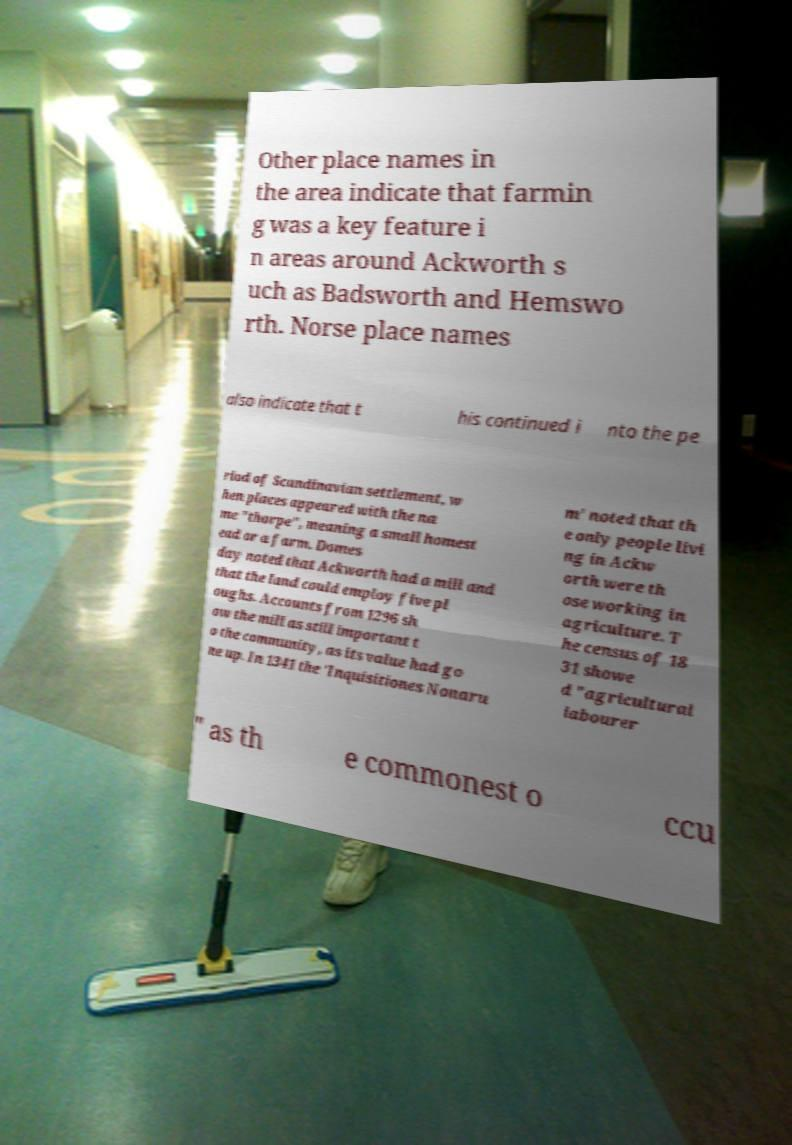Could you assist in decoding the text presented in this image and type it out clearly? Other place names in the area indicate that farmin g was a key feature i n areas around Ackworth s uch as Badsworth and Hemswo rth. Norse place names also indicate that t his continued i nto the pe riod of Scandinavian settlement, w hen places appeared with the na me "thorpe", meaning a small homest ead or a farm. Domes day noted that Ackworth had a mill and that the land could employ five pl oughs. Accounts from 1296 sh ow the mill as still important t o the community, as its value had go ne up. In 1341 the 'Inquisitiones Nonaru m' noted that th e only people livi ng in Ackw orth were th ose working in agriculture. T he census of 18 31 showe d "agricultural labourer " as th e commonest o ccu 